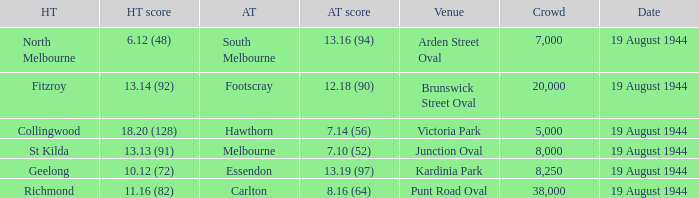What is Fitzroy's Home team Crowd? 20000.0. 